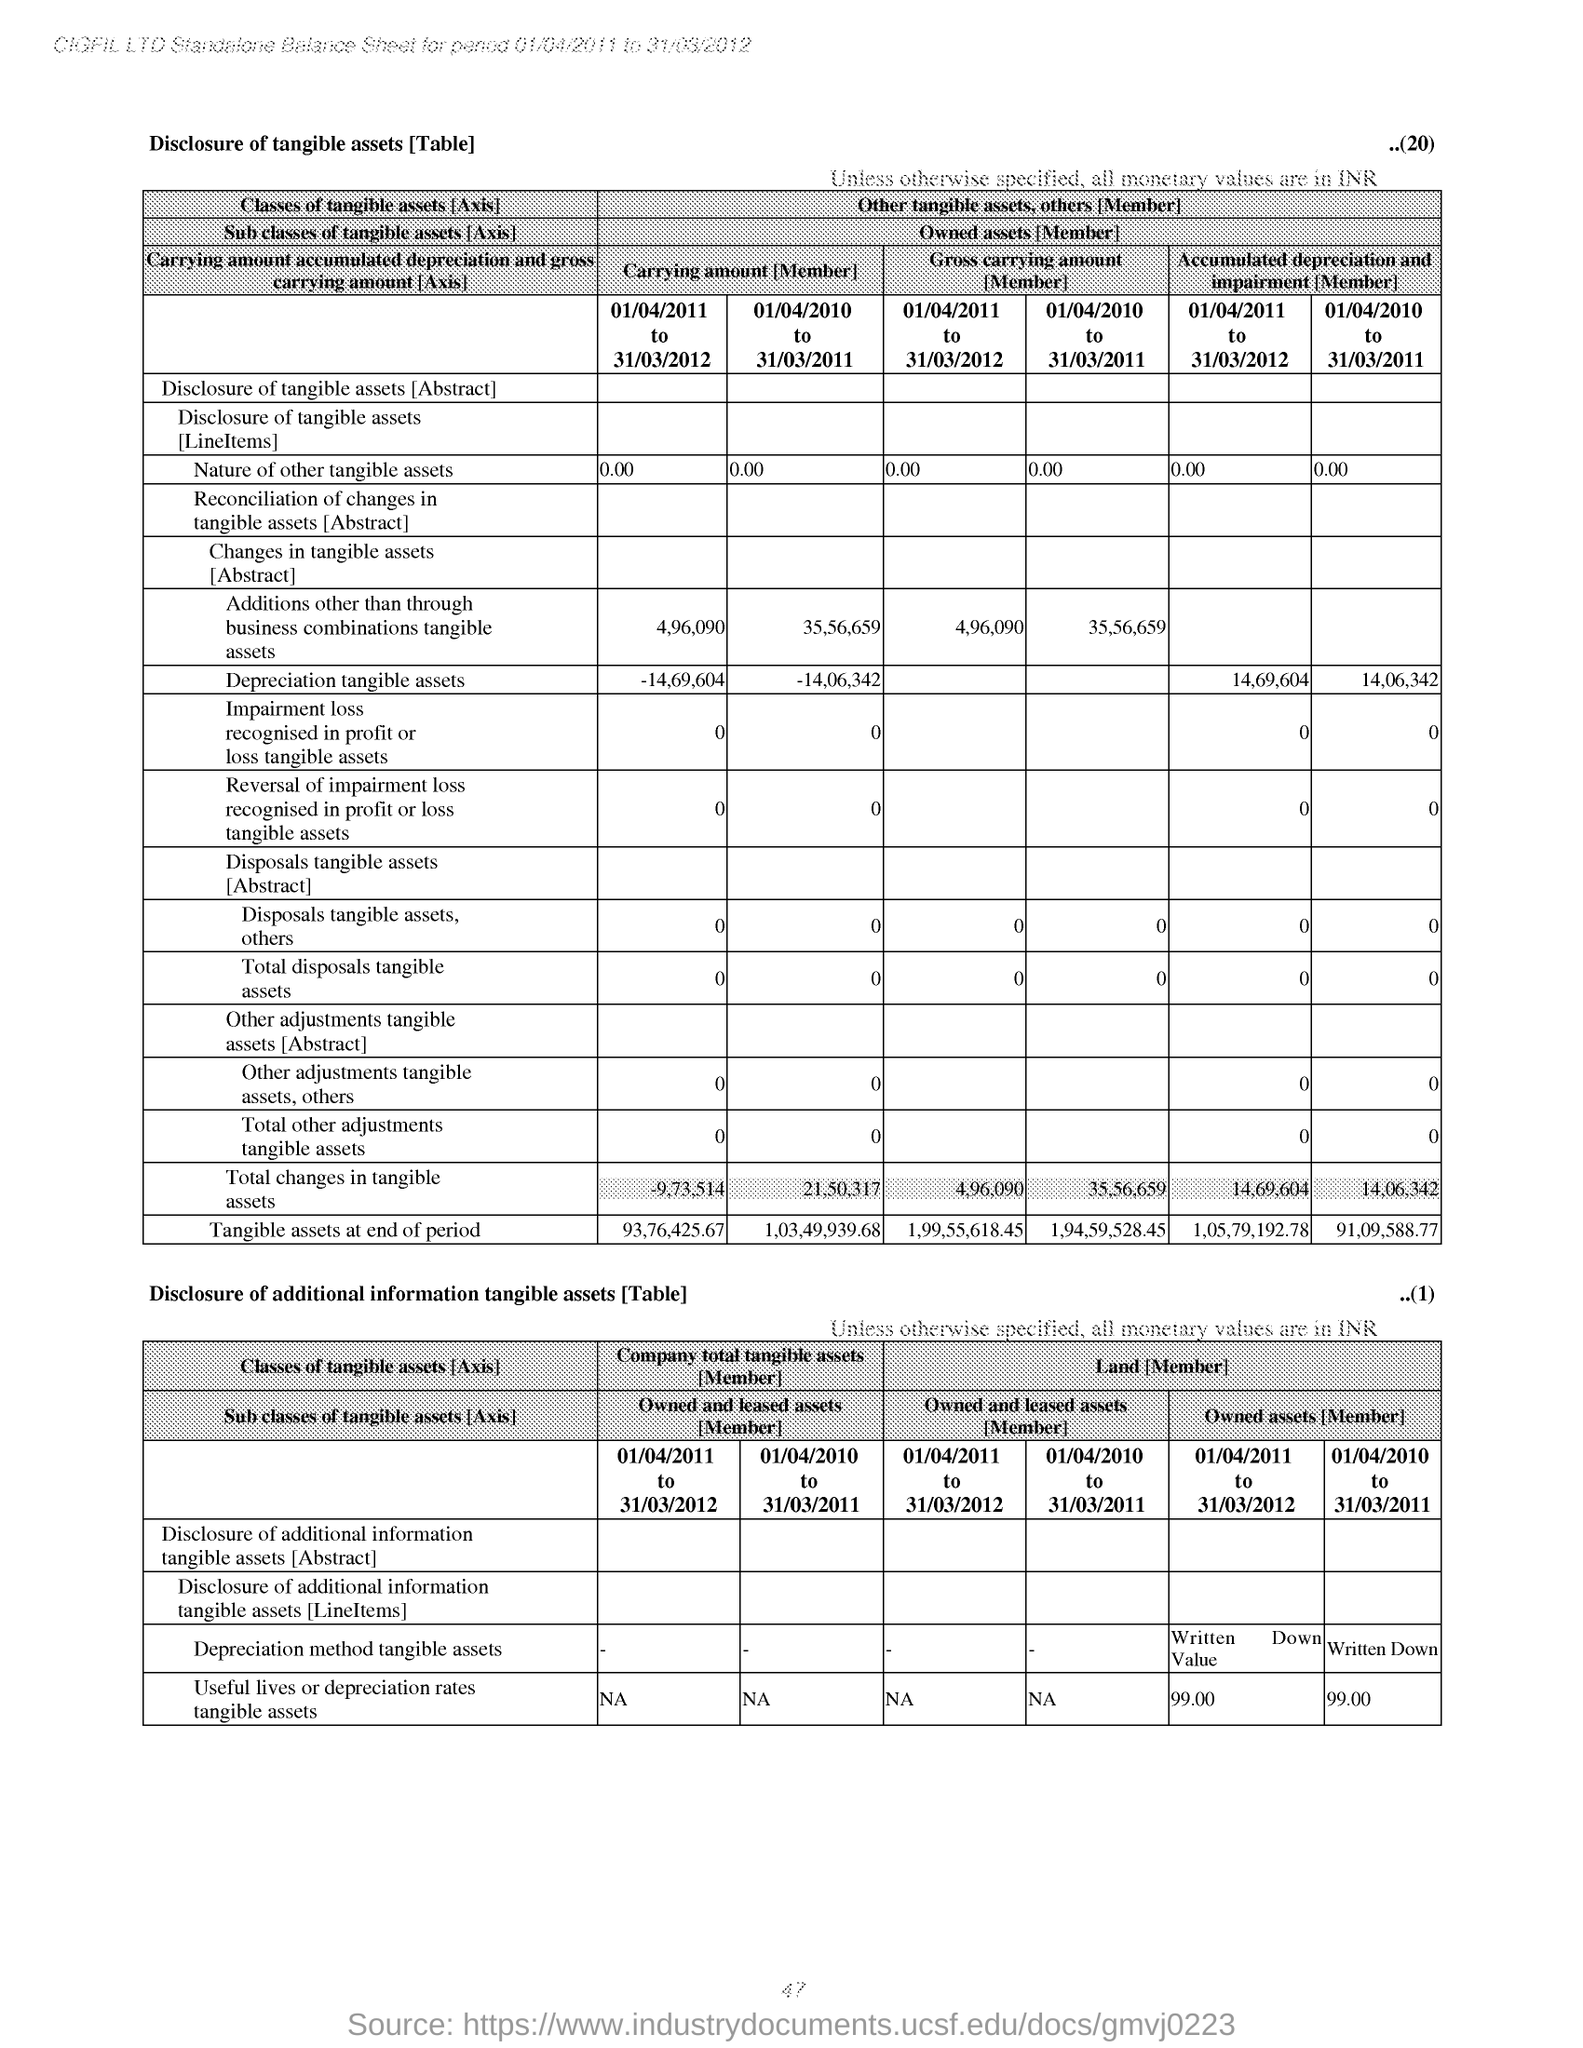Highlight a few significant elements in this photo. The "Owned Assets for the period 01/04/2011 to 31/03/2012 for 'Useful lives or depreciation rates tangible assets' in table 2 are 99. The period from 01/04/2010 to 31/03/2011 had the least amount of carrying amount for depreciation of tangible assets, according to Table 1. The accumulated depreciation and impairment for the period 01/04/2010 to 31/03/2011 for tangible assets depreciation is 14,06,342. 